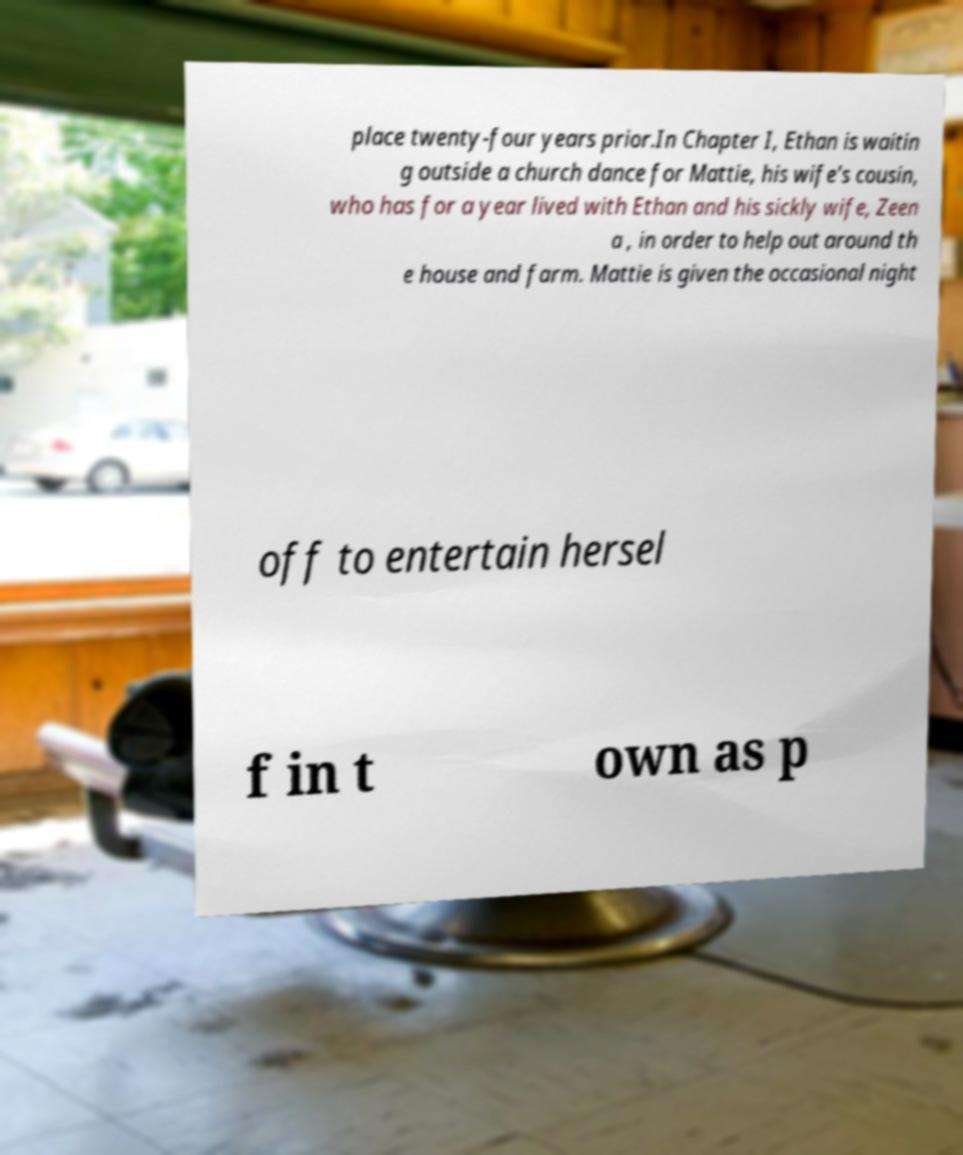For documentation purposes, I need the text within this image transcribed. Could you provide that? place twenty-four years prior.In Chapter I, Ethan is waitin g outside a church dance for Mattie, his wife's cousin, who has for a year lived with Ethan and his sickly wife, Zeen a , in order to help out around th e house and farm. Mattie is given the occasional night off to entertain hersel f in t own as p 